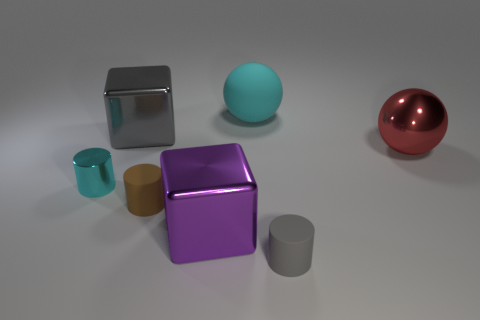Is the color of the matte thing that is behind the small metal cylinder the same as the metallic cylinder?
Give a very brief answer. Yes. What is the size of the brown cylinder?
Your answer should be very brief. Small. What size is the rubber cylinder on the left side of the small cylinder right of the brown rubber object?
Make the answer very short. Small. What number of metallic cylinders are the same color as the rubber sphere?
Make the answer very short. 1. What number of gray shiny things are there?
Your response must be concise. 1. How many blocks have the same material as the cyan cylinder?
Your answer should be compact. 2. What size is the other thing that is the same shape as the red object?
Your response must be concise. Large. What is the material of the brown cylinder?
Provide a succinct answer. Rubber. What is the material of the big sphere on the right side of the cylinder that is in front of the shiny block that is in front of the red thing?
Offer a very short reply. Metal. There is another large metal thing that is the same shape as the gray shiny object; what color is it?
Ensure brevity in your answer.  Purple. 